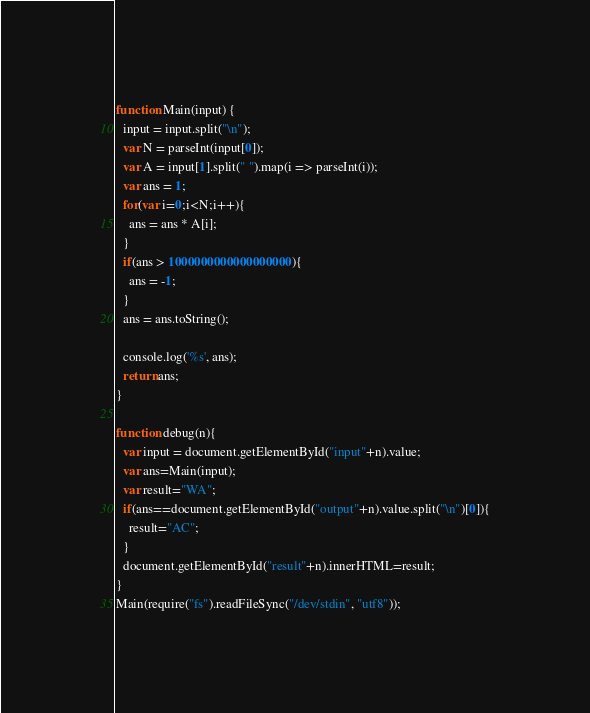<code> <loc_0><loc_0><loc_500><loc_500><_JavaScript_>function Main(input) {
  input = input.split("\n");
  var N = parseInt(input[0]);
  var A = input[1].split(" ").map(i => parseInt(i));
  var ans = 1;
  for(var i=0;i<N;i++){
    ans = ans * A[i];
  }
  if(ans > 1000000000000000000){
    ans = -1;
  }
  ans = ans.toString();

  console.log('%s', ans);
  return ans;
}

function debug(n){
  var input = document.getElementById("input"+n).value;
  var ans=Main(input);
  var result="WA";
  if(ans==document.getElementById("output"+n).value.split("\n")[0]){
    result="AC";
  }
  document.getElementById("result"+n).innerHTML=result;
}
Main(require("fs").readFileSync("/dev/stdin", "utf8"));</code> 